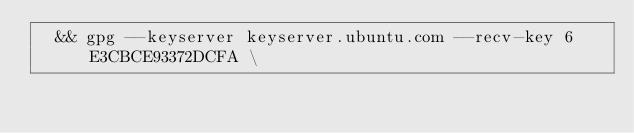Convert code to text. <code><loc_0><loc_0><loc_500><loc_500><_Dockerfile_>	&& gpg --keyserver keyserver.ubuntu.com --recv-key 6E3CBCE93372DCFA \</code> 